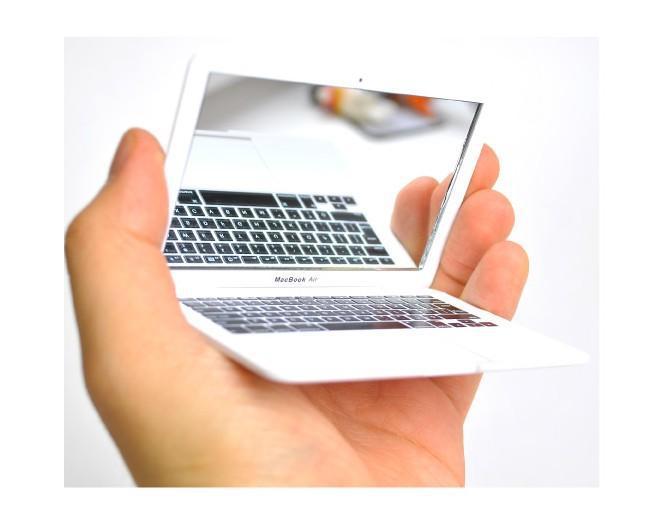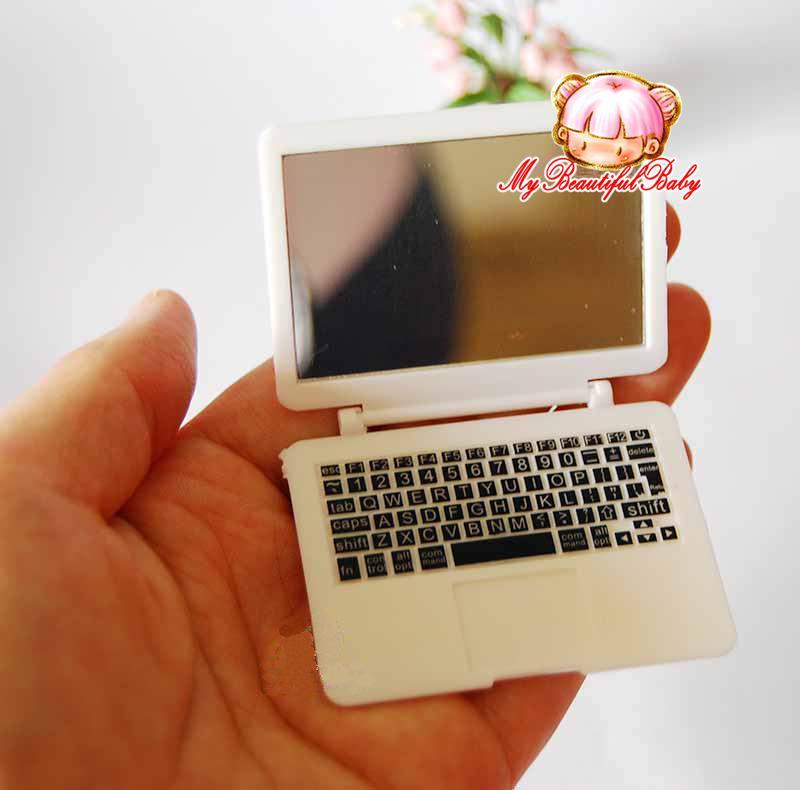The first image is the image on the left, the second image is the image on the right. For the images shown, is this caption "There are two miniature laptops." true? Answer yes or no. Yes. The first image is the image on the left, the second image is the image on the right. Assess this claim about the two images: "No single image contains more than two devices, and at least one image shows a hand holding a small white open device.". Correct or not? Answer yes or no. Yes. 